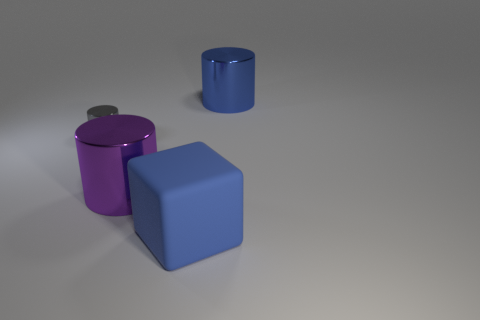Is there any other thing that has the same shape as the large rubber object?
Your answer should be compact. No. There is a cylinder that is on the right side of the blue block; is it the same color as the small shiny object?
Ensure brevity in your answer.  No. The other blue object that is the same shape as the small thing is what size?
Provide a short and direct response. Large. What number of large yellow cylinders are the same material as the large blue cylinder?
Provide a succinct answer. 0. Are there any gray things that are right of the blue thing that is in front of the blue thing behind the large blue cube?
Ensure brevity in your answer.  No. The big blue metal thing is what shape?
Your answer should be compact. Cylinder. Is the material of the cube that is right of the tiny gray cylinder the same as the cylinder on the right side of the rubber thing?
Keep it short and to the point. No. What number of big blocks have the same color as the big matte thing?
Make the answer very short. 0. What shape is the thing that is in front of the small metallic object and right of the big purple metallic object?
Offer a terse response. Cube. What is the color of the shiny cylinder that is both behind the purple shiny thing and right of the gray metallic cylinder?
Ensure brevity in your answer.  Blue. 